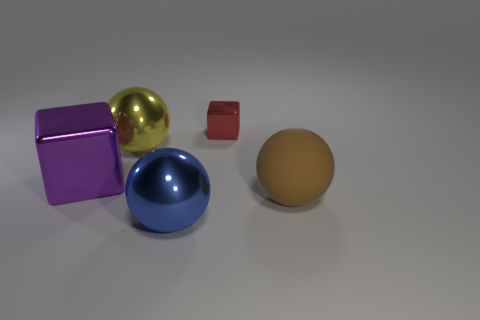There is a shiny ball behind the large matte thing; how many small cubes are on the right side of it?
Your answer should be compact. 1. Are there any blue shiny things that have the same shape as the large purple object?
Your answer should be compact. No. Does the ball behind the brown object have the same size as the object that is in front of the big brown sphere?
Your answer should be compact. Yes. There is a large object right of the large sphere that is in front of the large brown rubber thing; what shape is it?
Keep it short and to the point. Sphere. What number of blue shiny spheres have the same size as the blue metal thing?
Make the answer very short. 0. Is there a tiny cyan matte sphere?
Your response must be concise. No. Is there any other thing that is the same color as the large rubber ball?
Ensure brevity in your answer.  No. What is the shape of the tiny object that is the same material as the yellow ball?
Offer a terse response. Cube. What is the color of the shiny thing that is in front of the cube that is to the left of the object that is behind the yellow shiny thing?
Your response must be concise. Blue. Are there an equal number of large brown spheres behind the big yellow sphere and large green shiny balls?
Make the answer very short. Yes. 